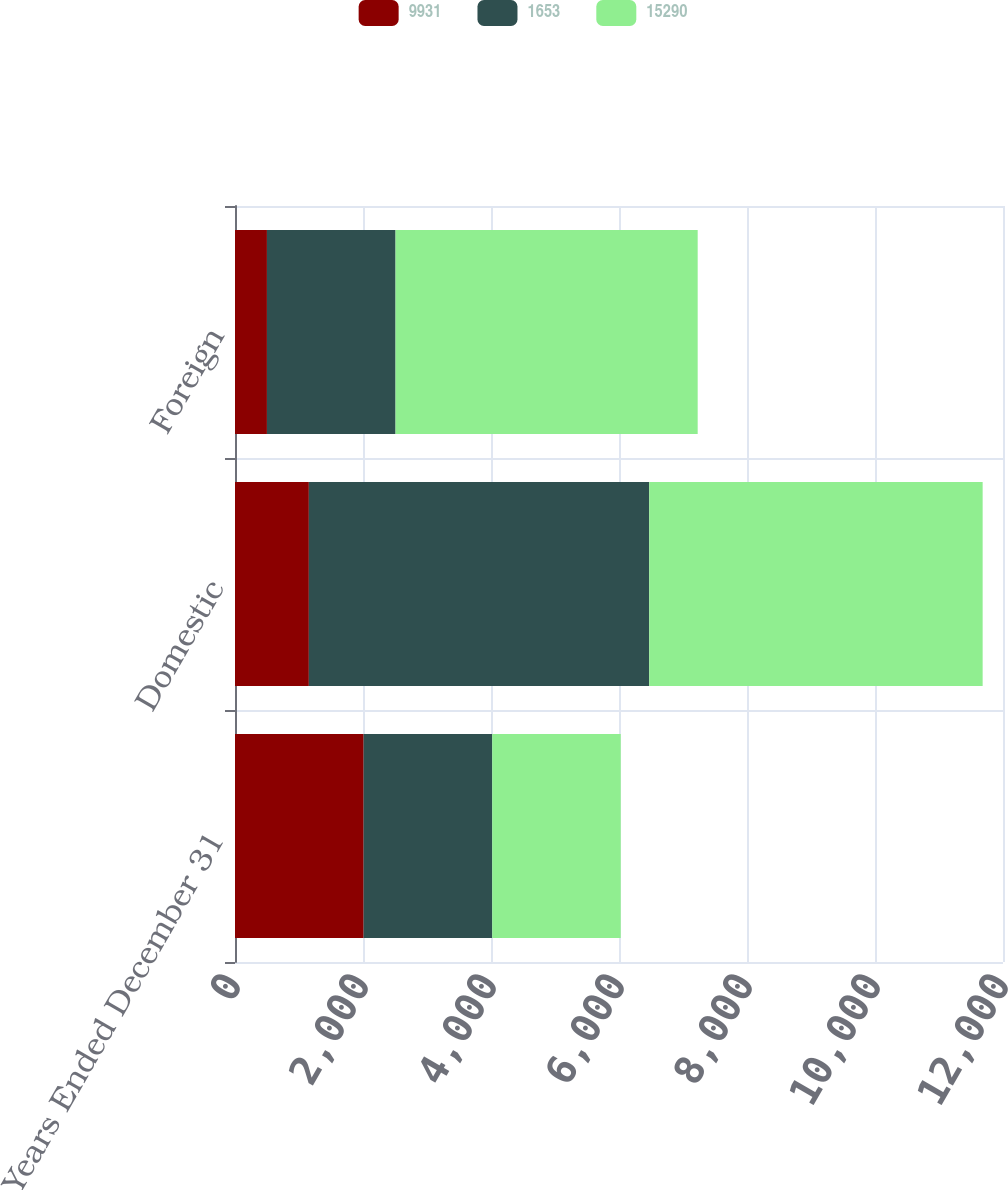Convert chart to OTSL. <chart><loc_0><loc_0><loc_500><loc_500><stacked_bar_chart><ecel><fcel>Years Ended December 31<fcel>Domestic<fcel>Foreign<nl><fcel>9931<fcel>2010<fcel>1154<fcel>499<nl><fcel>1653<fcel>2009<fcel>5318<fcel>2009.5<nl><fcel>15290<fcel>2008<fcel>5210<fcel>4721<nl></chart> 